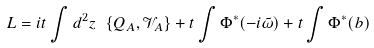Convert formula to latex. <formula><loc_0><loc_0><loc_500><loc_500>L = i t \int d ^ { 2 } z \ \{ Q _ { A } , \mathcal { V } _ { A } \} + t \int \Phi ^ { * } ( - i \tilde { \omega } ) + t \int \Phi ^ { * } ( b )</formula> 